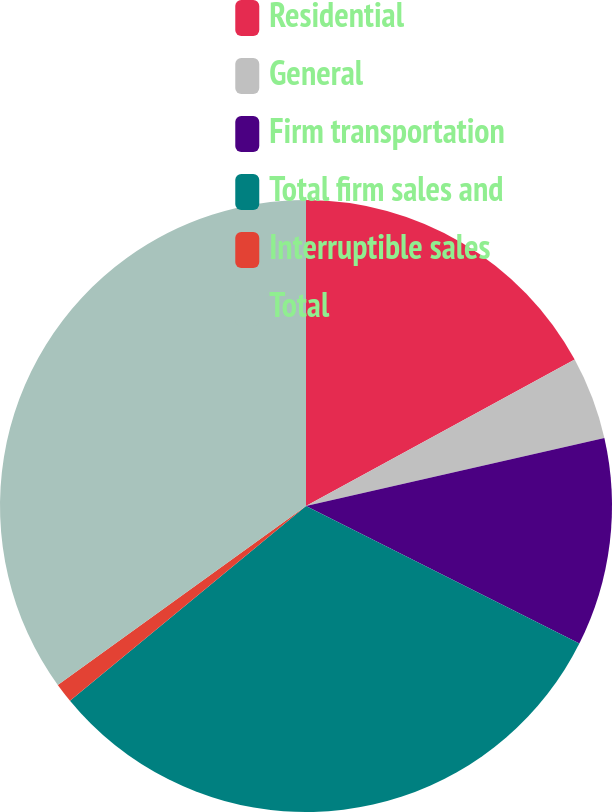<chart> <loc_0><loc_0><loc_500><loc_500><pie_chart><fcel>Residential<fcel>General<fcel>Firm transportation<fcel>Total firm sales and<fcel>Interruptible sales<fcel>Total<nl><fcel>17.06%<fcel>4.38%<fcel>10.98%<fcel>31.6%<fcel>1.04%<fcel>34.94%<nl></chart> 